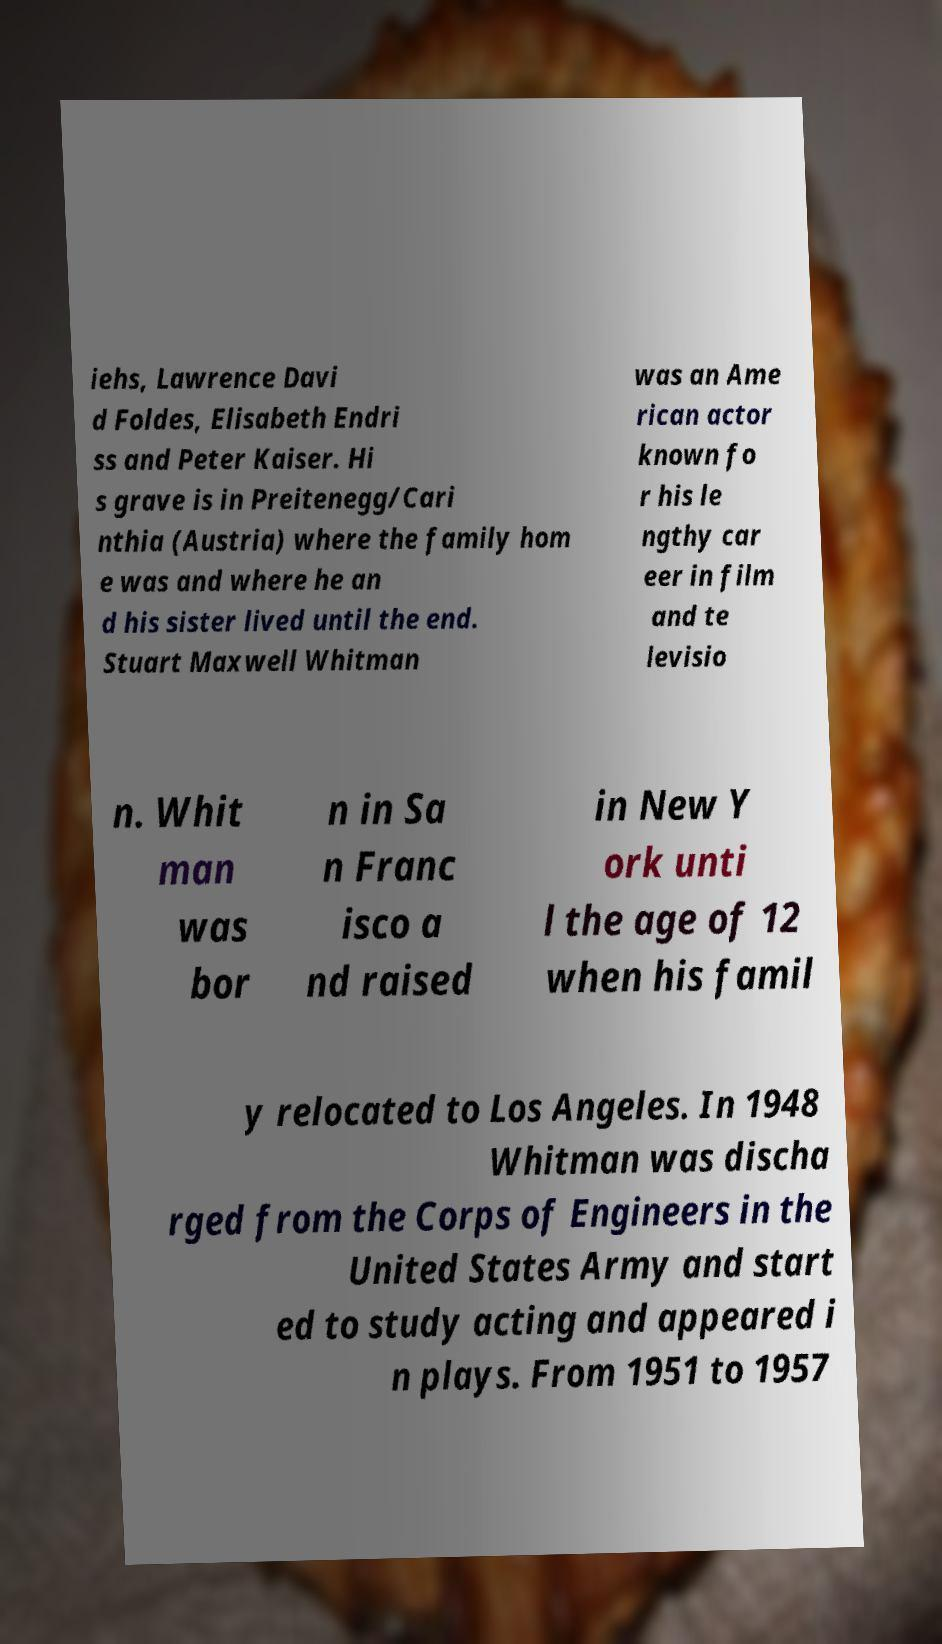For documentation purposes, I need the text within this image transcribed. Could you provide that? iehs, Lawrence Davi d Foldes, Elisabeth Endri ss and Peter Kaiser. Hi s grave is in Preitenegg/Cari nthia (Austria) where the family hom e was and where he an d his sister lived until the end. Stuart Maxwell Whitman was an Ame rican actor known fo r his le ngthy car eer in film and te levisio n. Whit man was bor n in Sa n Franc isco a nd raised in New Y ork unti l the age of 12 when his famil y relocated to Los Angeles. In 1948 Whitman was discha rged from the Corps of Engineers in the United States Army and start ed to study acting and appeared i n plays. From 1951 to 1957 